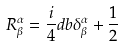<formula> <loc_0><loc_0><loc_500><loc_500>R _ { \beta } ^ { \alpha } = \frac { i } { 4 } d b \delta _ { \beta } ^ { \alpha } + \frac { 1 } { 2 }</formula> 